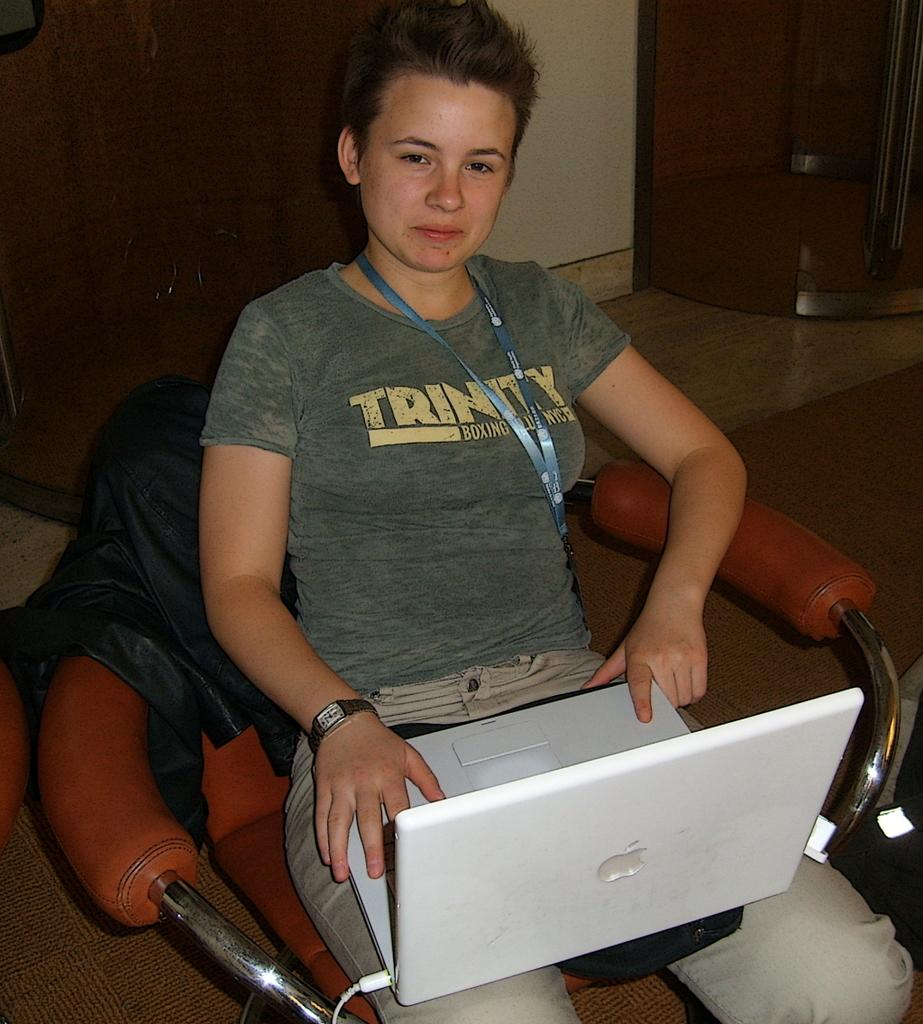What is the person in the image doing? The person is sitting on a chair in the image. What object is the person holding? The person is holding a laptop on her lap. What can be seen behind the person in the image? There are walls visible in the background of the image. What surface is the person sitting on? There is a floor visible in the image. Can you see any fairies flying around the person in the image? No, there are no fairies present in the image. What type of engine is powering the laptop in the image? The image does not provide information about the laptop's engine, as laptops are powered by batteries or electricity and do not have engines. 